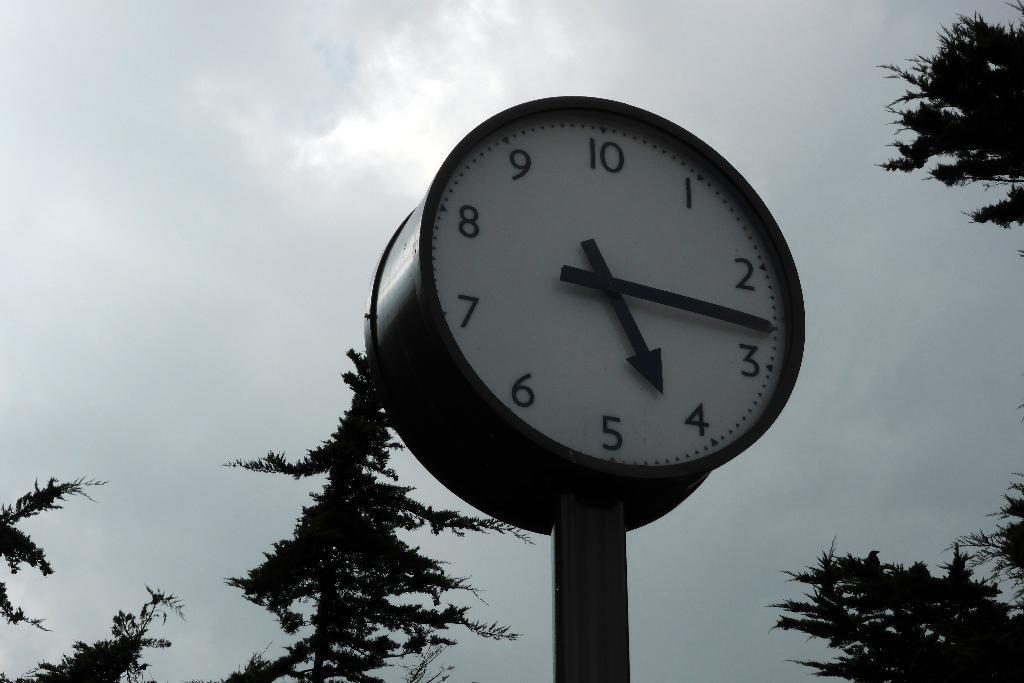Please provide a concise description of this image. In this image we can see a clock, trees and in the background, we can see the sky. 